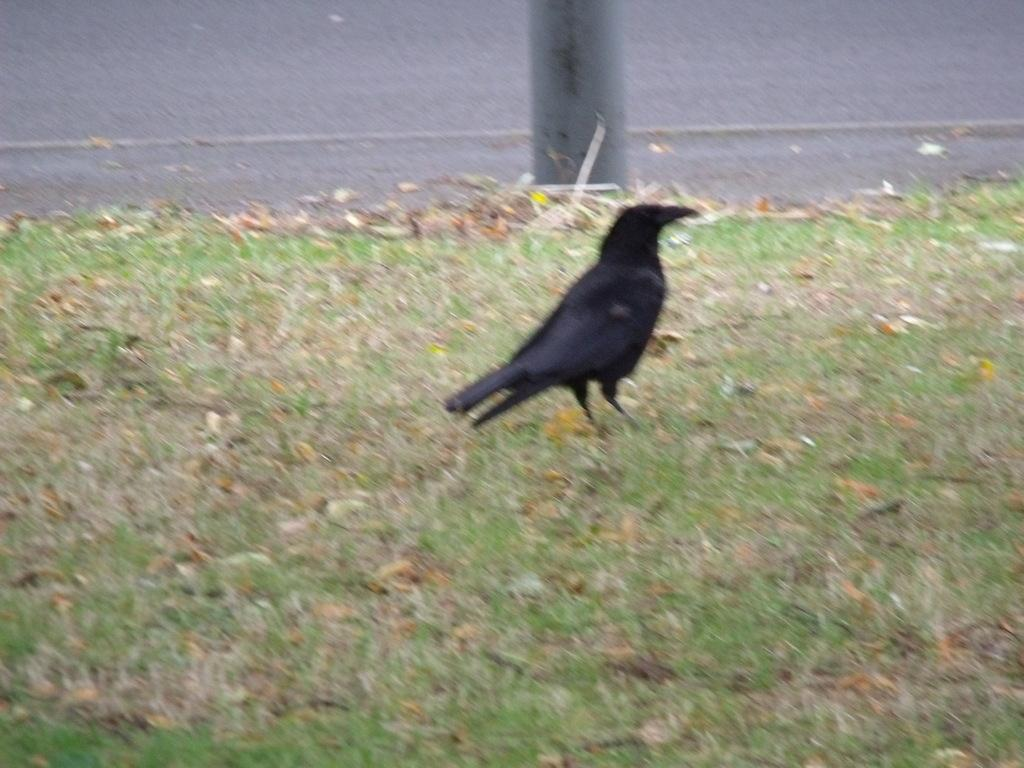What type of bird is in the image? There is a crow in the image. What color is the crow? The crow is black in color. What type of vegetation is present in the image? There is grass and dried leaves in the image. What structures can be seen in the image? There is a pole and a road in the image. How many shoes are visible in the image? There are no shoes present in the image. What type of brick is used to construct the pole in the image? There is no pole made of bricks in the image; the pole is a separate structure. 